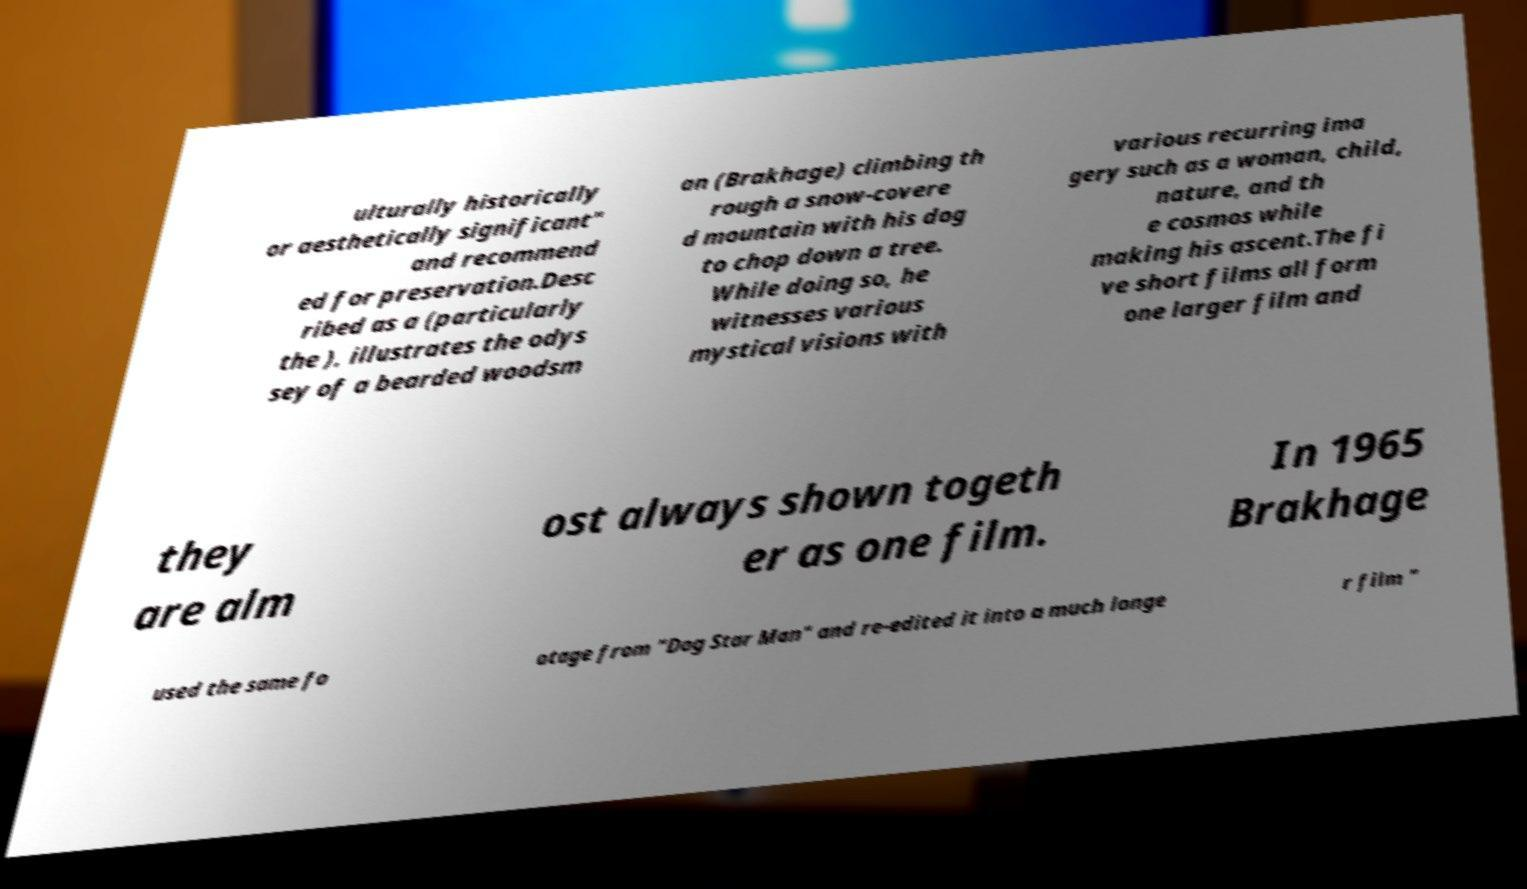I need the written content from this picture converted into text. Can you do that? ulturally historically or aesthetically significant" and recommend ed for preservation.Desc ribed as a (particularly the ), illustrates the odys sey of a bearded woodsm an (Brakhage) climbing th rough a snow-covere d mountain with his dog to chop down a tree. While doing so, he witnesses various mystical visions with various recurring ima gery such as a woman, child, nature, and th e cosmos while making his ascent.The fi ve short films all form one larger film and they are alm ost always shown togeth er as one film. In 1965 Brakhage used the same fo otage from "Dog Star Man" and re-edited it into a much longe r film " 